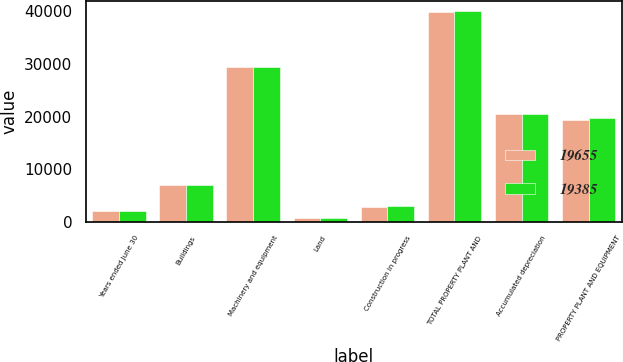Convert chart. <chart><loc_0><loc_0><loc_500><loc_500><stacked_bar_chart><ecel><fcel>Years ended June 30<fcel>Buildings<fcel>Machinery and equipment<fcel>Land<fcel>Construction in progress<fcel>TOTAL PROPERTY PLANT AND<fcel>Accumulated depreciation<fcel>PROPERTY PLANT AND EQUIPMENT<nl><fcel>19655<fcel>2016<fcel>6885<fcel>29506<fcel>769<fcel>2706<fcel>39866<fcel>20481<fcel>19385<nl><fcel>19385<fcel>2015<fcel>6949<fcel>29420<fcel>763<fcel>2931<fcel>40063<fcel>20408<fcel>19655<nl></chart> 